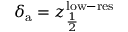Convert formula to latex. <formula><loc_0><loc_0><loc_500><loc_500>\delta _ { a } = z _ { \frac { 1 } { 2 } } ^ { l o w - r e s }</formula> 